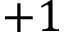<formula> <loc_0><loc_0><loc_500><loc_500>+ 1</formula> 